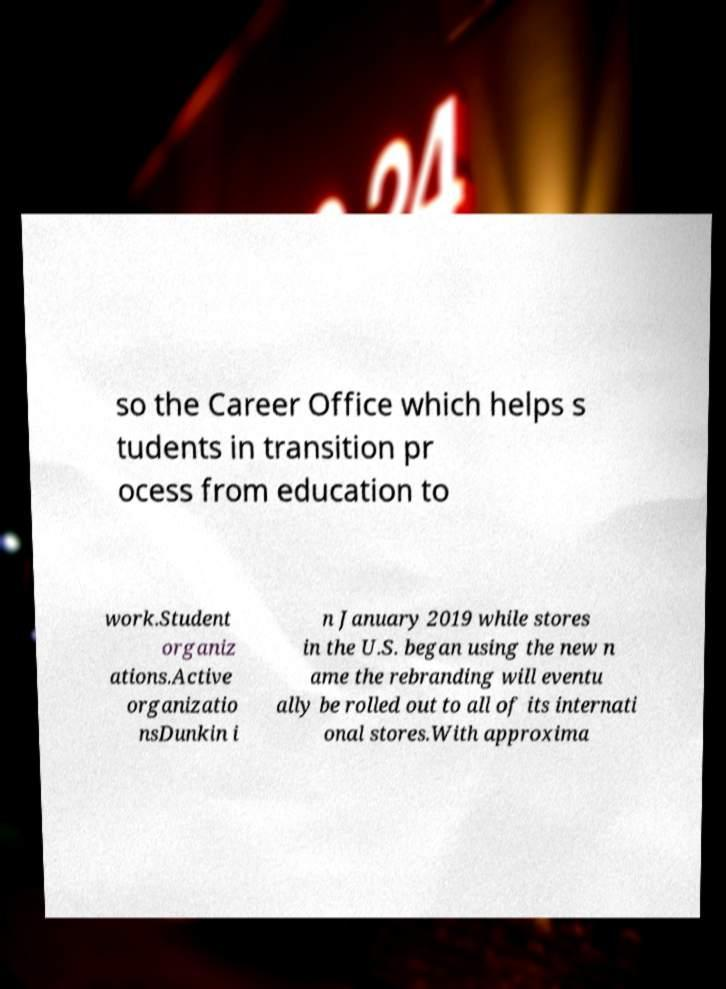Could you assist in decoding the text presented in this image and type it out clearly? so the Career Office which helps s tudents in transition pr ocess from education to work.Student organiz ations.Active organizatio nsDunkin i n January 2019 while stores in the U.S. began using the new n ame the rebranding will eventu ally be rolled out to all of its internati onal stores.With approxima 